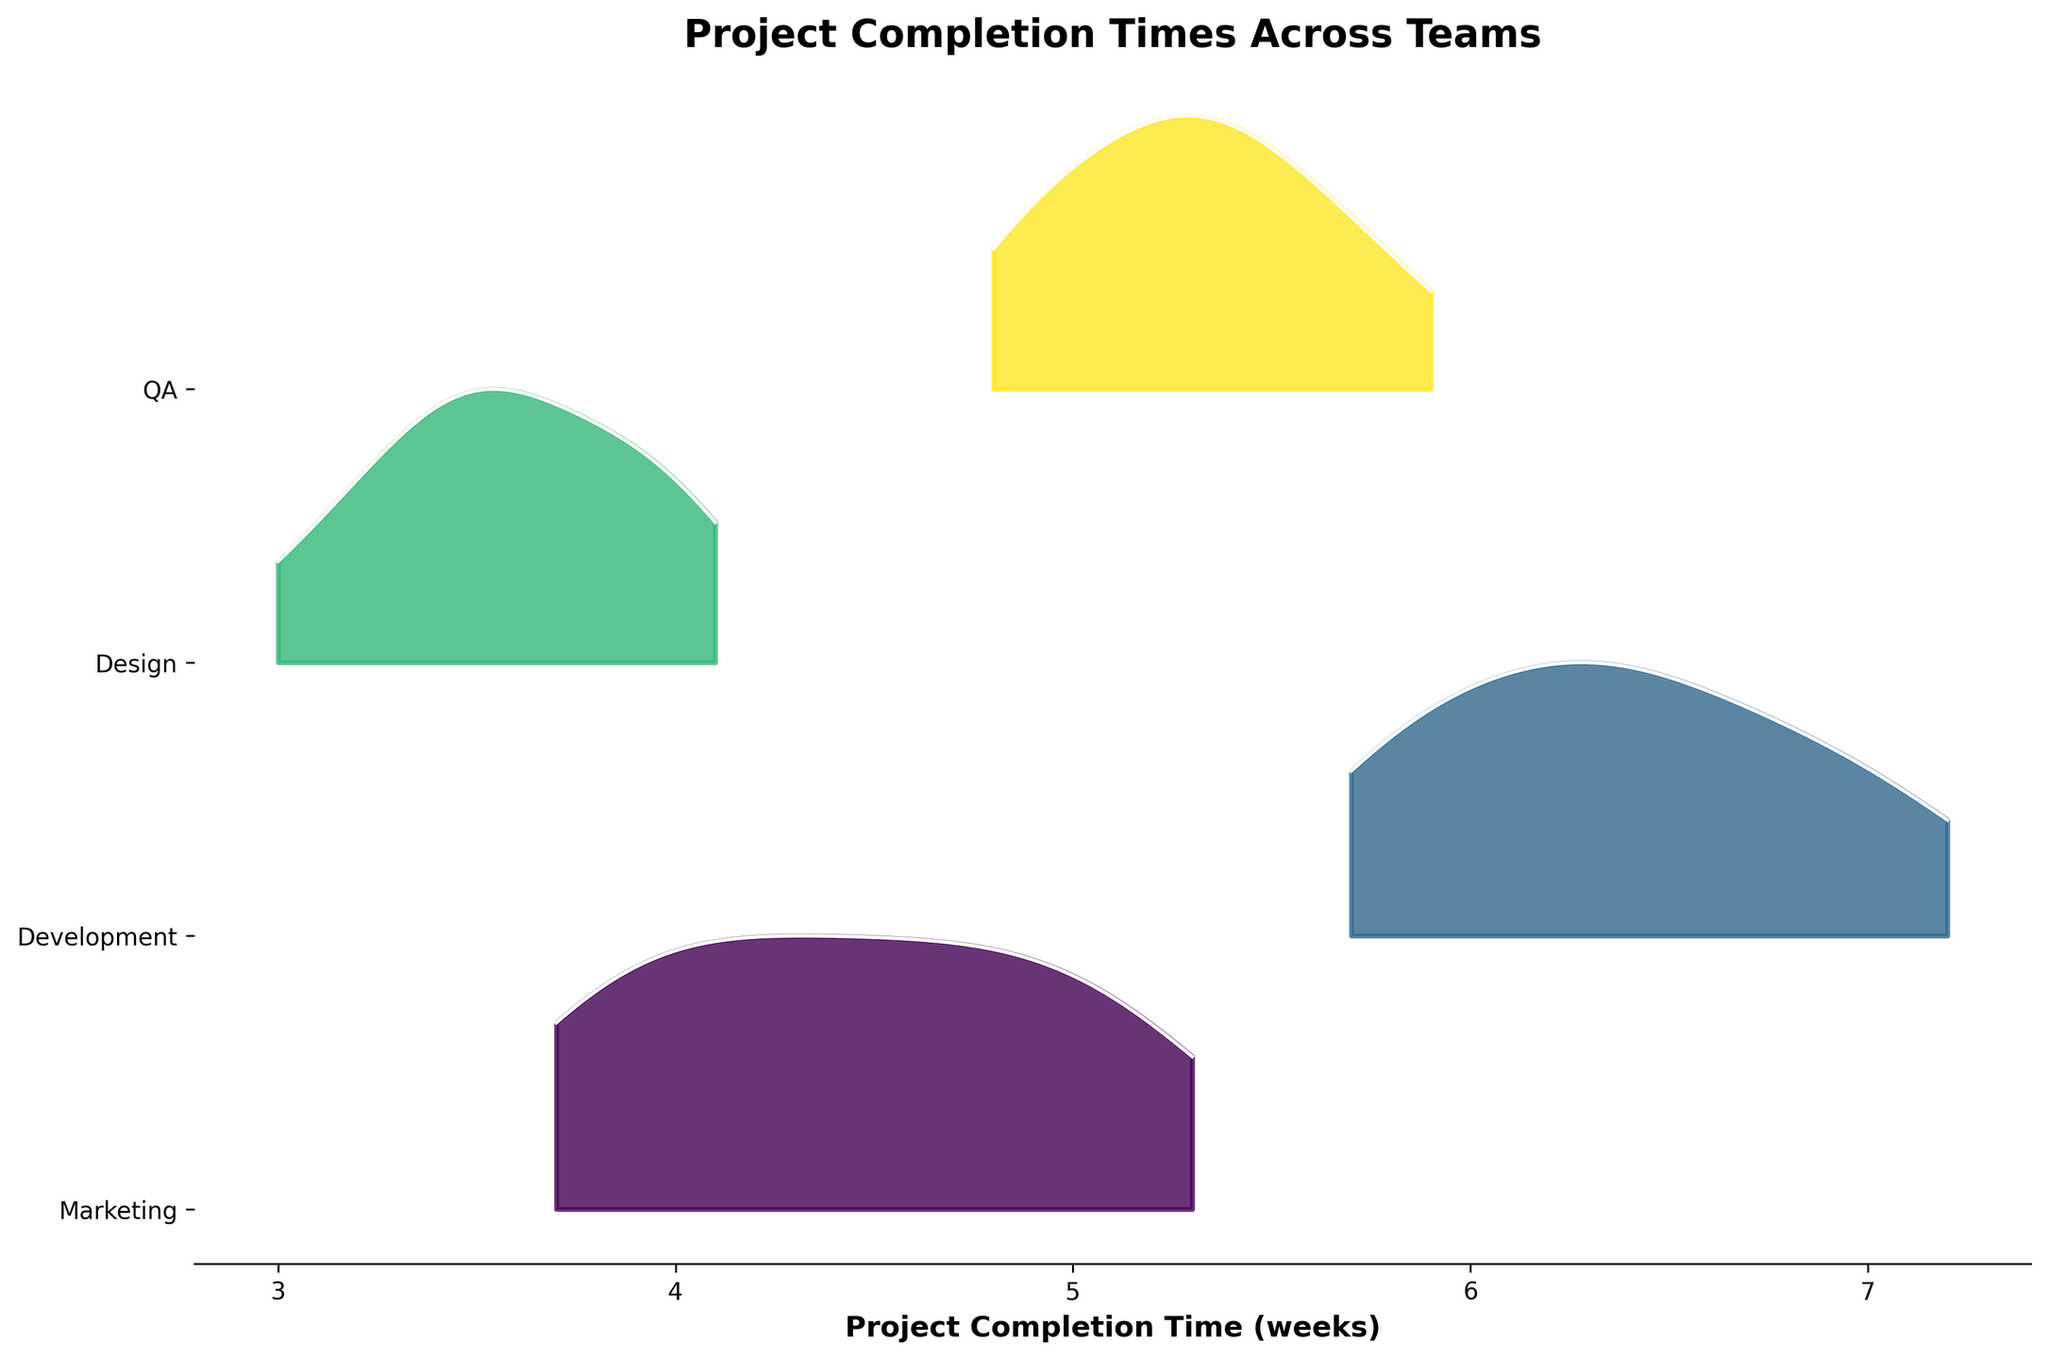What's the title of the figure? The title of a figure is usually located at the top and provides a brief description of the data presented.
Answer: Project Completion Times Across Teams Which team has the highest project completion time on average? Look at the ridgelines and their average height along the x-axis for each team. The Development team's ridgeline appears further to the right, indicating higher completion times.
Answer: Development What's the range of completion times for the Design team? Check the spread of the Design team's ridgeline plot from left to right on the x-axis. The Design team's completion times range from 3.0 to 4.1 weeks.
Answer: 3.0 to 4.1 weeks How many different teams are represented in the figure? Observe the number of distinct ridgelines, each corresponding to a team. There are four ridgelines for Marketing, Development, Design, and QA teams.
Answer: 4 Which team has the most variations in project completion times? The team with the widest ridgeline (spread along the x-axis) has the most variations. Development team's ridgeline is wider compared to others, indicating the most variation.
Answer: Development How does the completion time of the QA team compare with that of the Marketing team? Compare the x-axis positions of the QA and Marketing team ridgelines. QA's ridgeline is to the right of Marketing's, indicating longer completion times.
Answer: QA team has longer completion times than Marketing Which month shows the highest completion time peak for the Marketing team? Identify the peaks in the Marketing team's ridgeline. The peak around 5.3 weeks corresponds to July.
Answer: July What can be inferred about the completion times of the Development team in comparison to the Design team? Compare the ridgelines for the Development and Design teams. The Development team's ridgeline is further to the right and more spread out, indicating generally higher and more variable completion times.
Answer: Development team has higher and more variable completion times than Design What's the most common completion time for the QA team? Look for the highest density peak in the QA team's ridgeline. The highest peak is around 5.3 weeks.
Answer: 5.3 weeks Which team has the smallest variation in completion times? The team with the narrowest ridgeline indicates the smallest variation. The Design team's ridgeline is the narrowest, indicating the least variation.
Answer: Design 